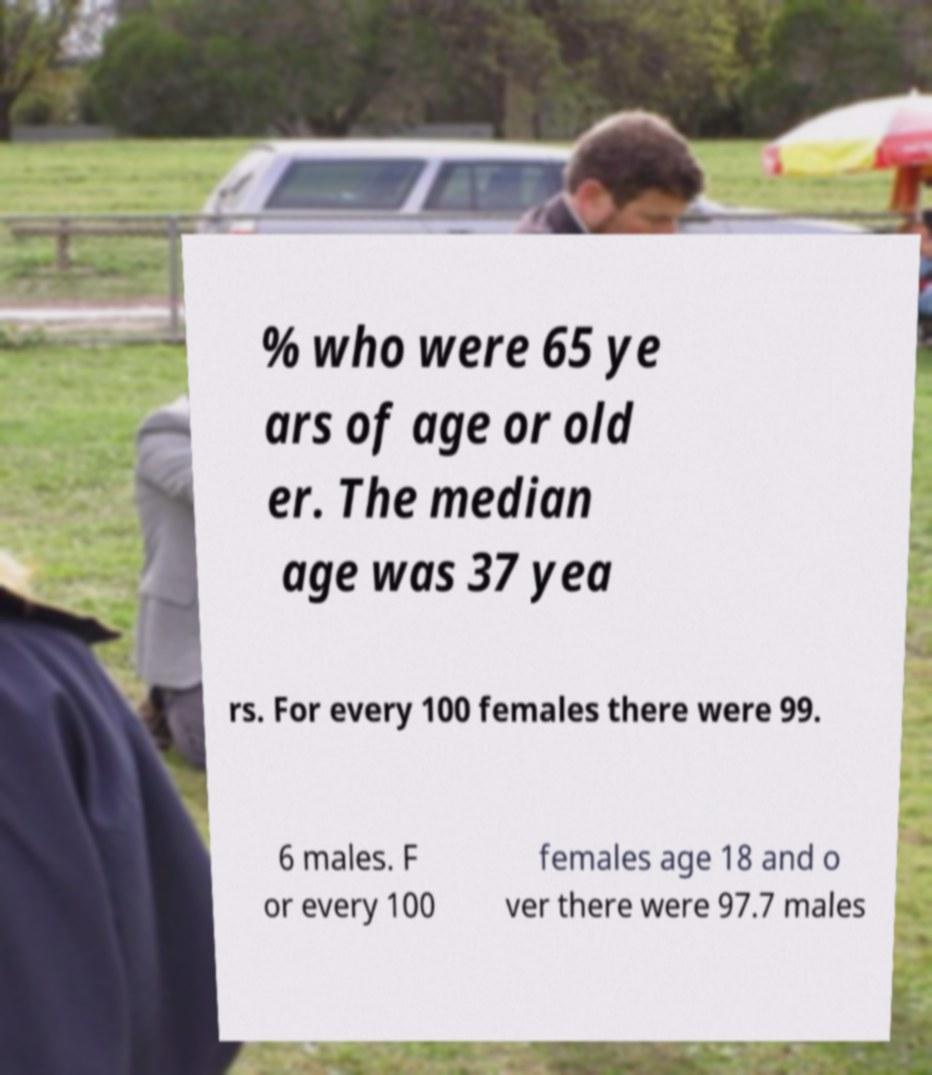Please read and relay the text visible in this image. What does it say? % who were 65 ye ars of age or old er. The median age was 37 yea rs. For every 100 females there were 99. 6 males. F or every 100 females age 18 and o ver there were 97.7 males 